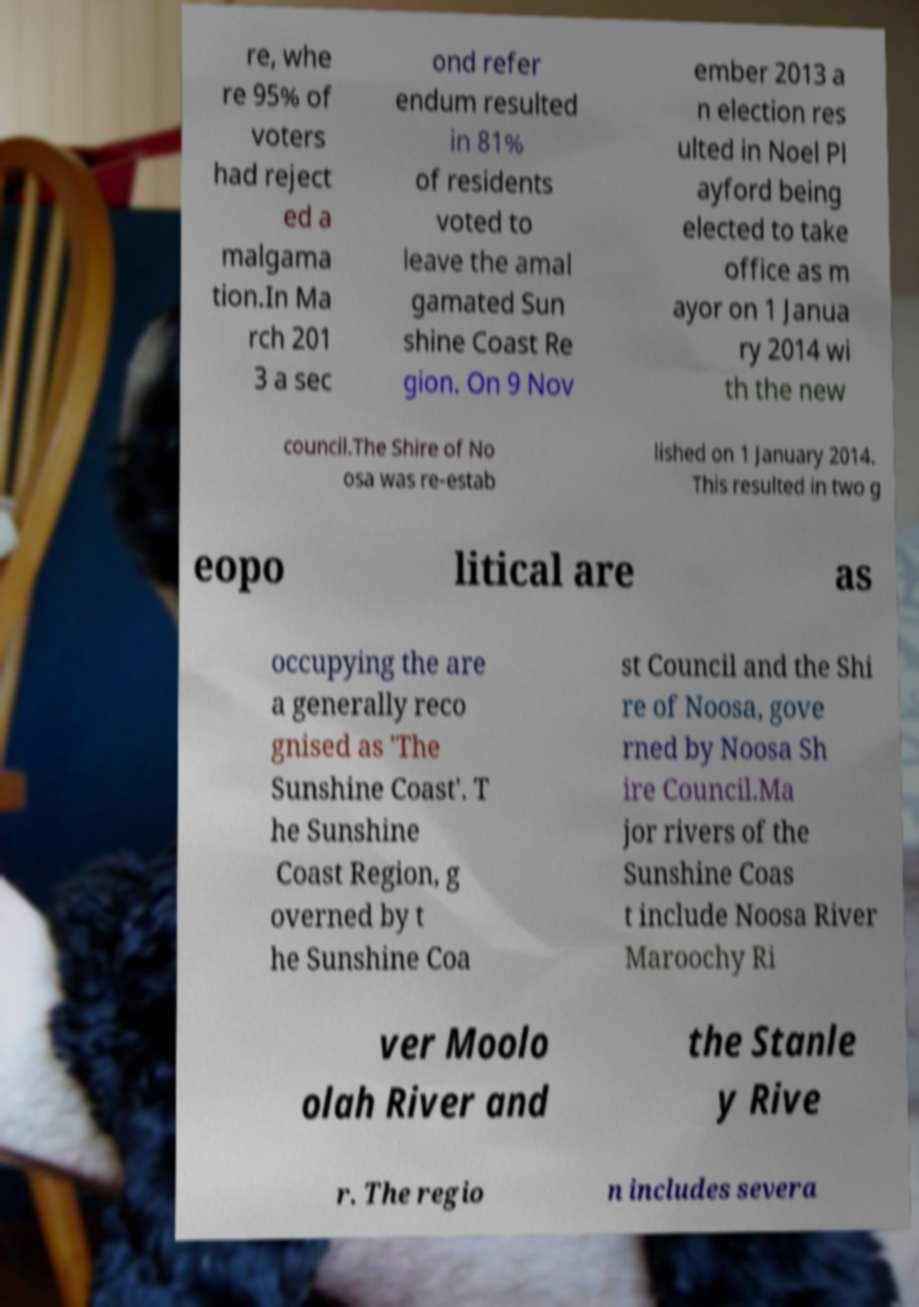Please identify and transcribe the text found in this image. re, whe re 95% of voters had reject ed a malgama tion.In Ma rch 201 3 a sec ond refer endum resulted in 81% of residents voted to leave the amal gamated Sun shine Coast Re gion. On 9 Nov ember 2013 a n election res ulted in Noel Pl ayford being elected to take office as m ayor on 1 Janua ry 2014 wi th the new council.The Shire of No osa was re-estab lished on 1 January 2014. This resulted in two g eopo litical are as occupying the are a generally reco gnised as 'The Sunshine Coast'. T he Sunshine Coast Region, g overned by t he Sunshine Coa st Council and the Shi re of Noosa, gove rned by Noosa Sh ire Council.Ma jor rivers of the Sunshine Coas t include Noosa River Maroochy Ri ver Moolo olah River and the Stanle y Rive r. The regio n includes severa 